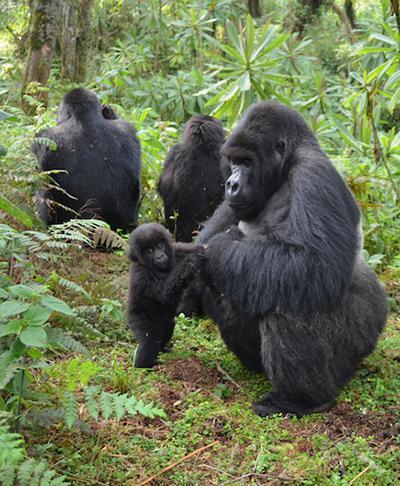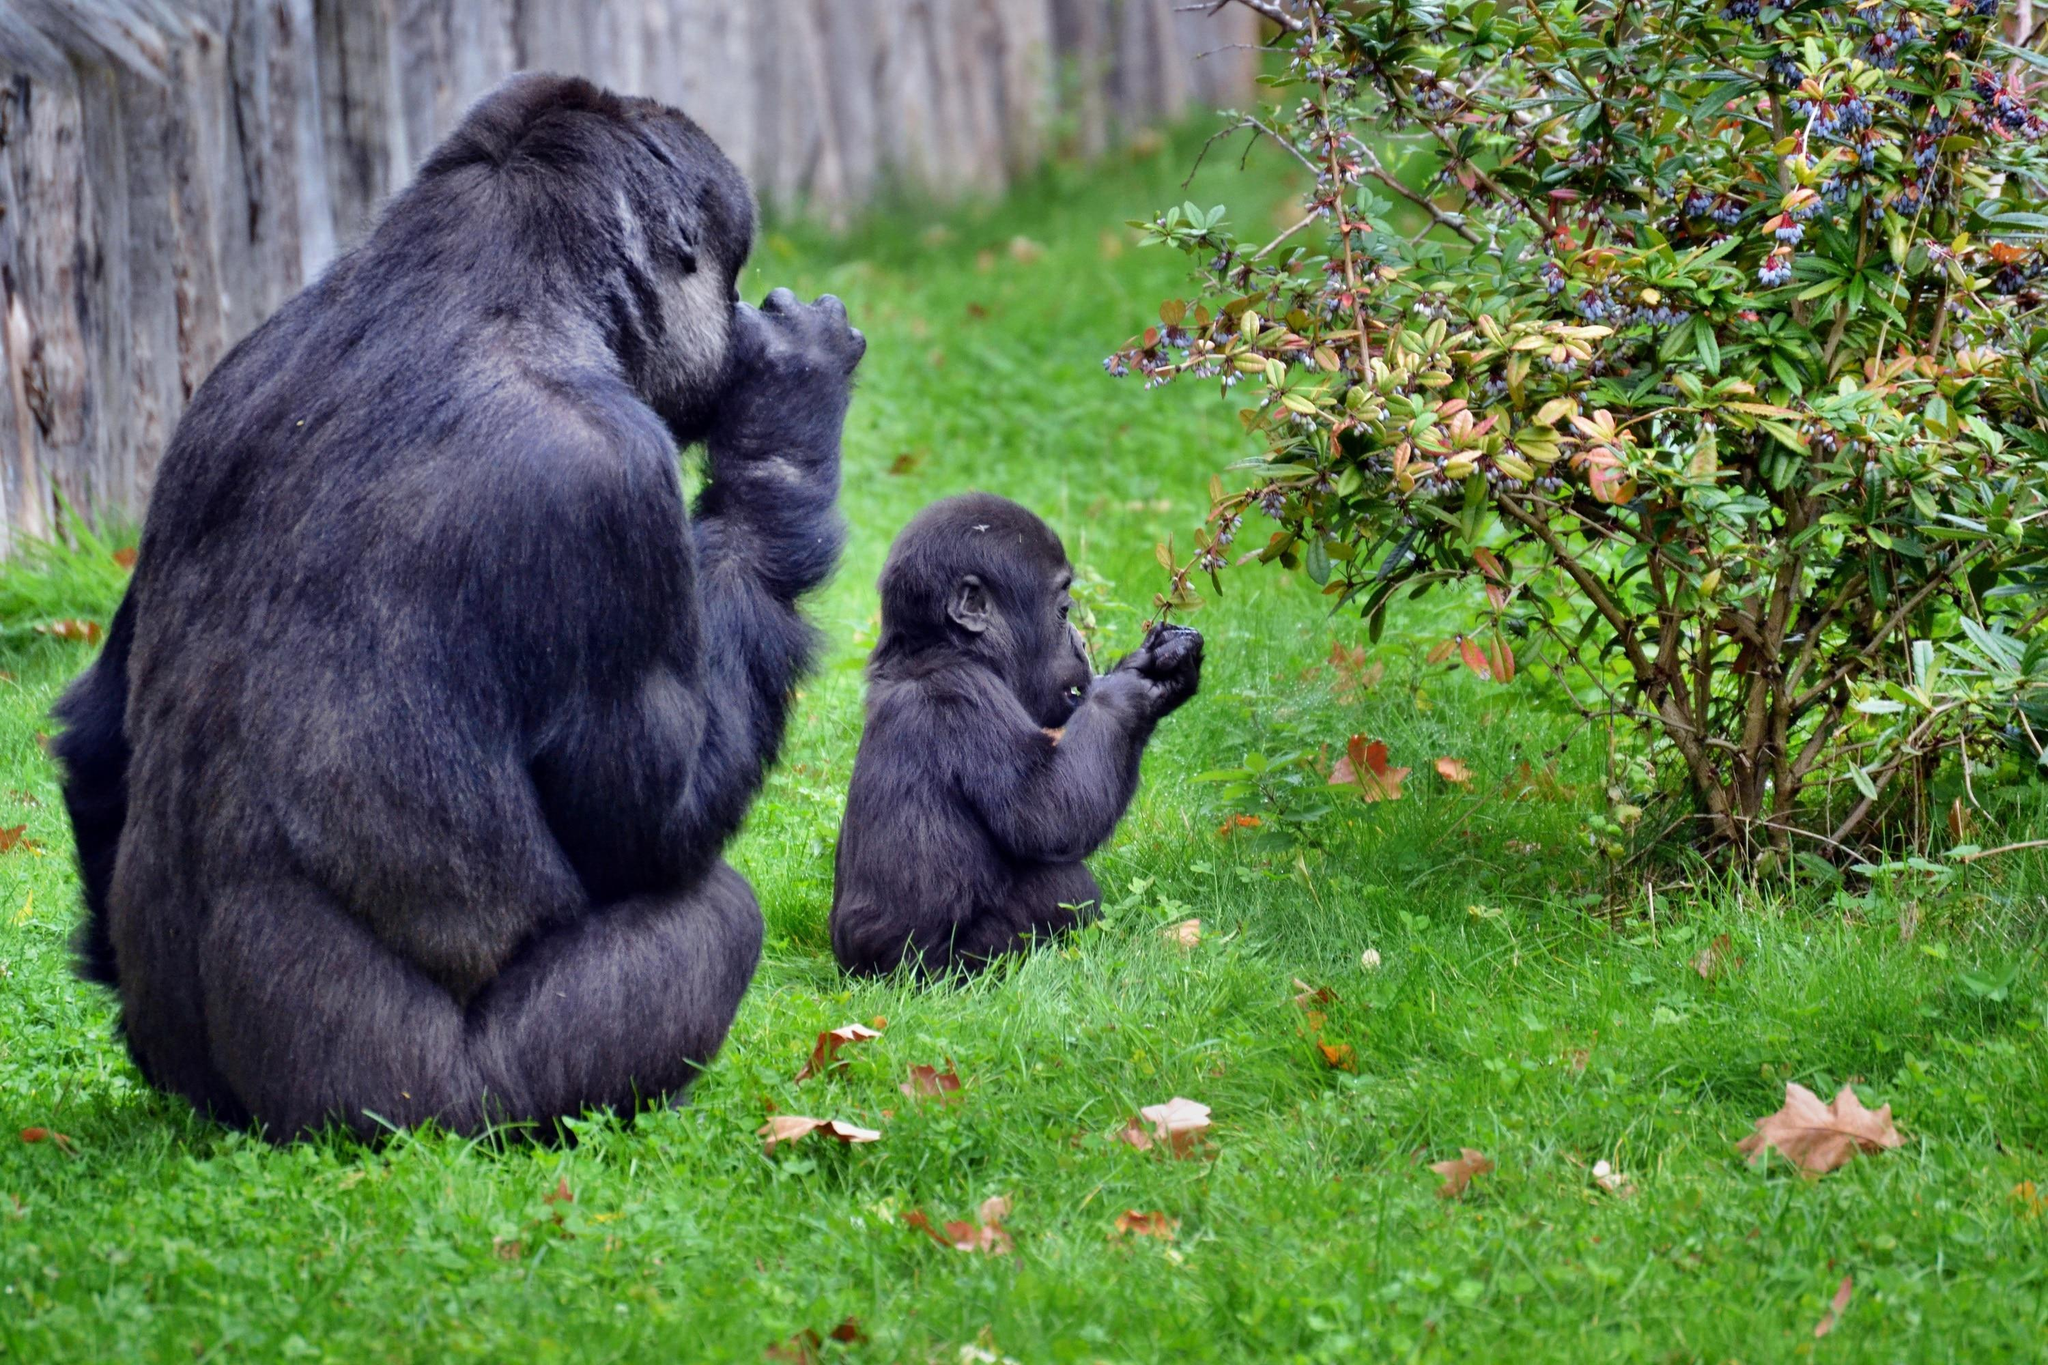The first image is the image on the left, the second image is the image on the right. For the images shown, is this caption "An image with no more than three gorillas shows an adult sitting behind a small juvenile ape." true? Answer yes or no. Yes. The first image is the image on the left, the second image is the image on the right. For the images shown, is this caption "There are exactly two animals in the image on the right." true? Answer yes or no. Yes. 